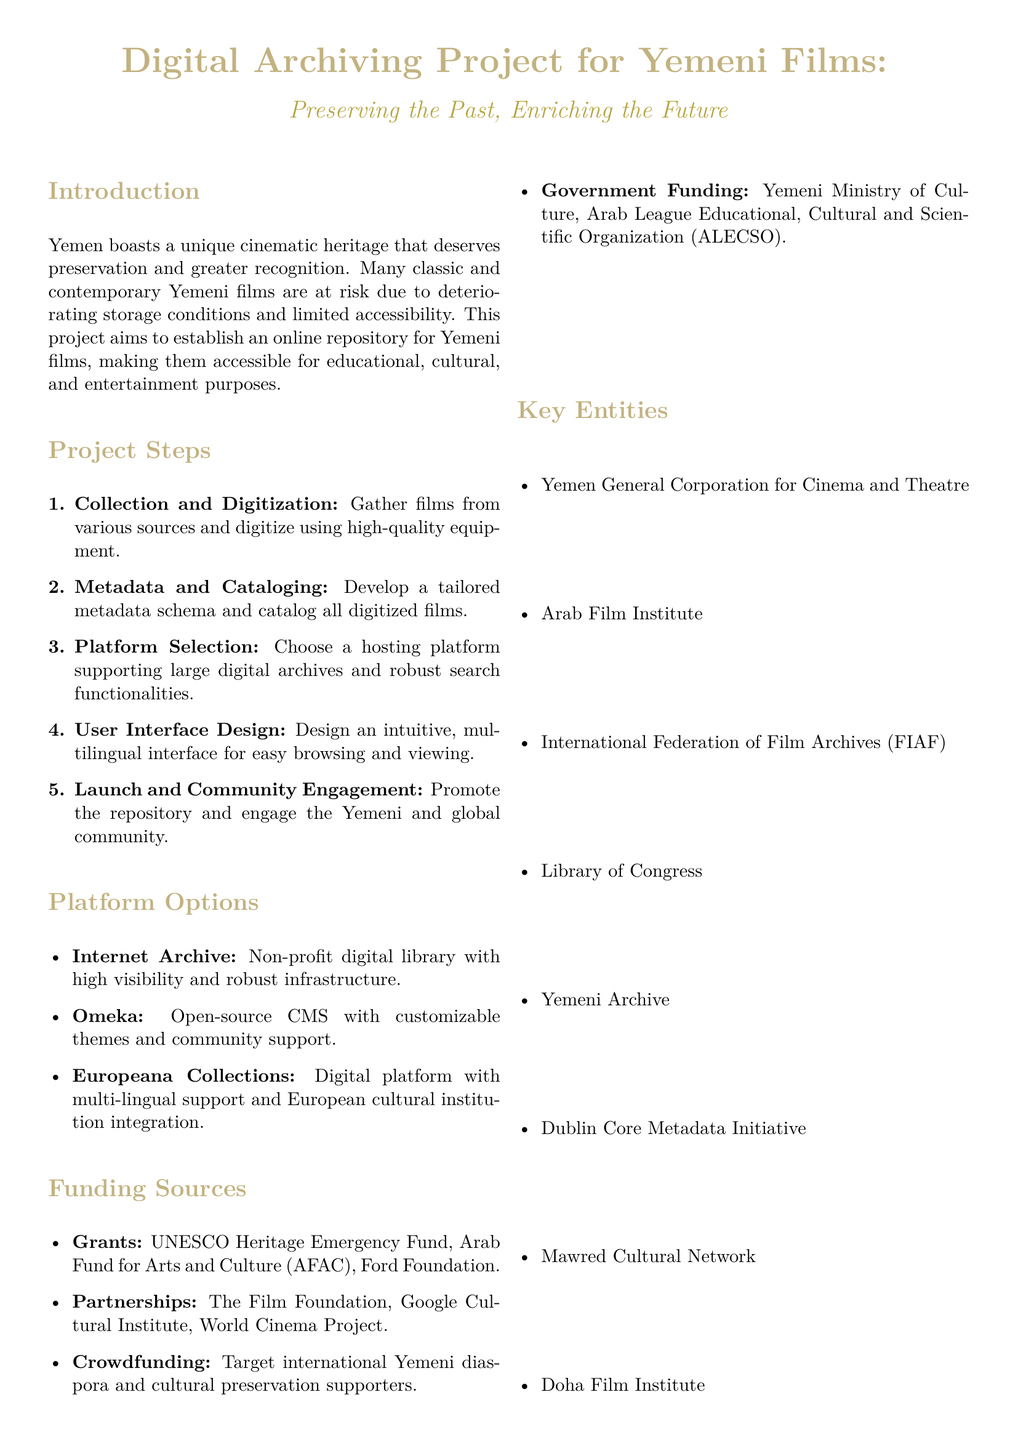What is the title of the proposal? The title of the proposal is stated at the beginning and outlines the project's focus on digital archiving.
Answer: Digital Archiving Project for Yemeni Films What are the first three steps in the project? The document lists the steps for the project sequentially, and the first three are crucial for initiating the project.
Answer: Collection and Digitization, Metadata and Cataloging, Platform Selection Which platform is non-profit and supports digital libraries? The document mentions specific platforms, and one is highlighted for its non-profit nature and services offered.
Answer: Internet Archive What funding source is mentioned that focuses on arts and culture? One of the listed funding sources is specifically identified as supporting arts and culture initiatives.
Answer: Arab Fund for Arts and Culture How long is the entire project timeline estimated to be? The timeline section of the document notes the overall duration of the project from planning to launch.
Answer: 18 months Which entity is included that focuses on film preservation? The document lists key entities that may contribute to or collaborate on the project, highlighting one focused on film.
Answer: International Federation of Film Archives What is the expected outcome related to accessibility? The expected outcomes include specific improvements on access to Yemeni films, reflecting the project's goals.
Answer: Increased accessibility to Yemeni films globally What is the role of the person providing contact information? The document provides contact information for the project coordinator, clarifying their role within the initiative.
Answer: Project Coordinator 